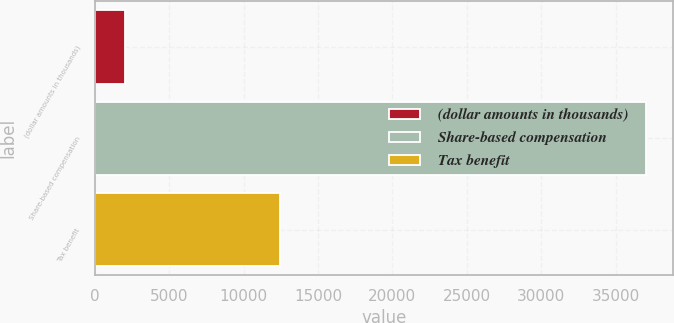Convert chart. <chart><loc_0><loc_0><loc_500><loc_500><bar_chart><fcel>(dollar amounts in thousands)<fcel>Share-based compensation<fcel>Tax benefit<nl><fcel>2013<fcel>37007<fcel>12472<nl></chart> 